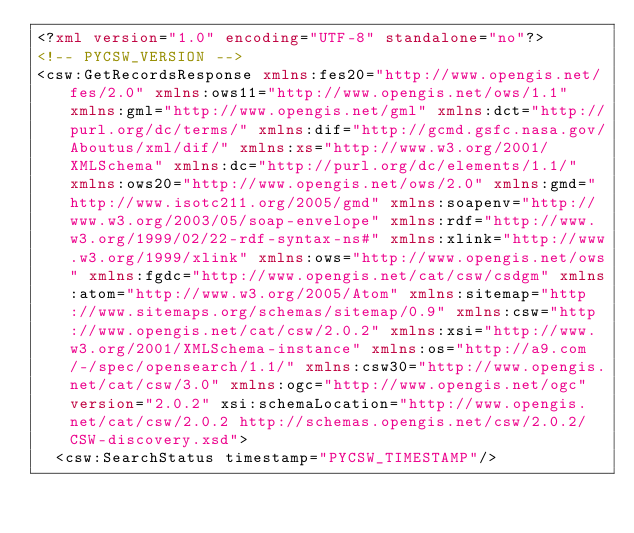<code> <loc_0><loc_0><loc_500><loc_500><_XML_><?xml version="1.0" encoding="UTF-8" standalone="no"?>
<!-- PYCSW_VERSION -->
<csw:GetRecordsResponse xmlns:fes20="http://www.opengis.net/fes/2.0" xmlns:ows11="http://www.opengis.net/ows/1.1" xmlns:gml="http://www.opengis.net/gml" xmlns:dct="http://purl.org/dc/terms/" xmlns:dif="http://gcmd.gsfc.nasa.gov/Aboutus/xml/dif/" xmlns:xs="http://www.w3.org/2001/XMLSchema" xmlns:dc="http://purl.org/dc/elements/1.1/" xmlns:ows20="http://www.opengis.net/ows/2.0" xmlns:gmd="http://www.isotc211.org/2005/gmd" xmlns:soapenv="http://www.w3.org/2003/05/soap-envelope" xmlns:rdf="http://www.w3.org/1999/02/22-rdf-syntax-ns#" xmlns:xlink="http://www.w3.org/1999/xlink" xmlns:ows="http://www.opengis.net/ows" xmlns:fgdc="http://www.opengis.net/cat/csw/csdgm" xmlns:atom="http://www.w3.org/2005/Atom" xmlns:sitemap="http://www.sitemaps.org/schemas/sitemap/0.9" xmlns:csw="http://www.opengis.net/cat/csw/2.0.2" xmlns:xsi="http://www.w3.org/2001/XMLSchema-instance" xmlns:os="http://a9.com/-/spec/opensearch/1.1/" xmlns:csw30="http://www.opengis.net/cat/csw/3.0" xmlns:ogc="http://www.opengis.net/ogc" version="2.0.2" xsi:schemaLocation="http://www.opengis.net/cat/csw/2.0.2 http://schemas.opengis.net/csw/2.0.2/CSW-discovery.xsd">
  <csw:SearchStatus timestamp="PYCSW_TIMESTAMP"/></code> 